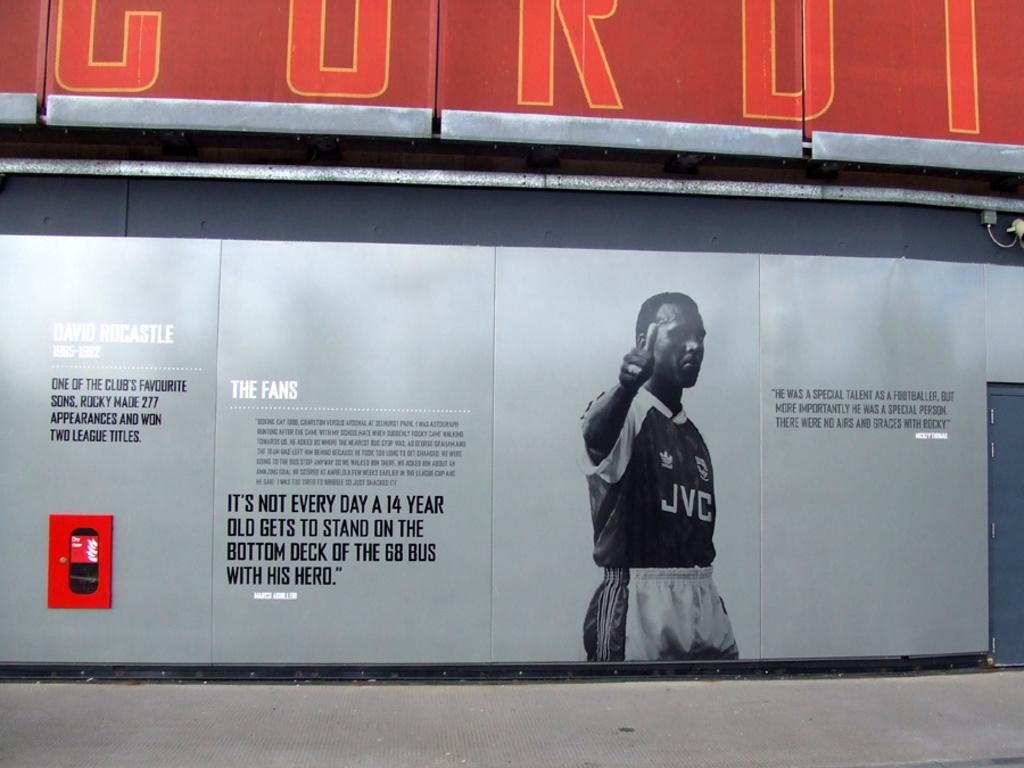<image>
Share a concise interpretation of the image provided. David Rocastle is depicted on a sign with the letters JVC on his shirt. 